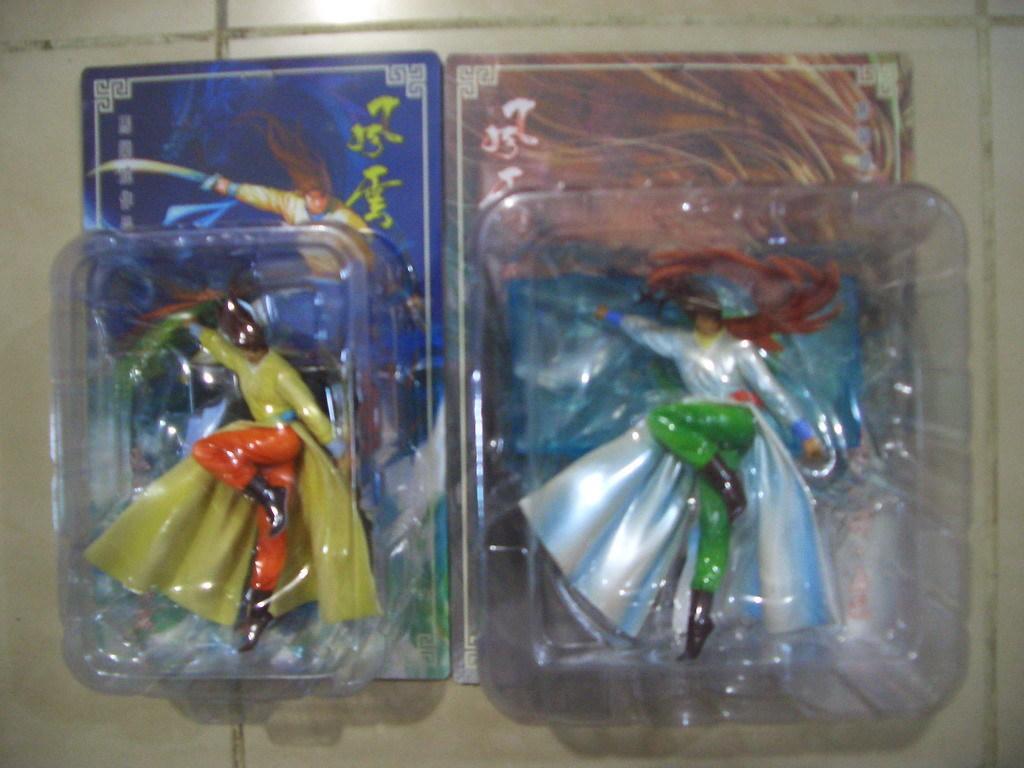In one or two sentences, can you explain what this image depicts? In this picture there are two plastic boxes on the floor. On the right there is a green color toy. On the left there is another boy who is wearing orange color trouser and yellow top. 